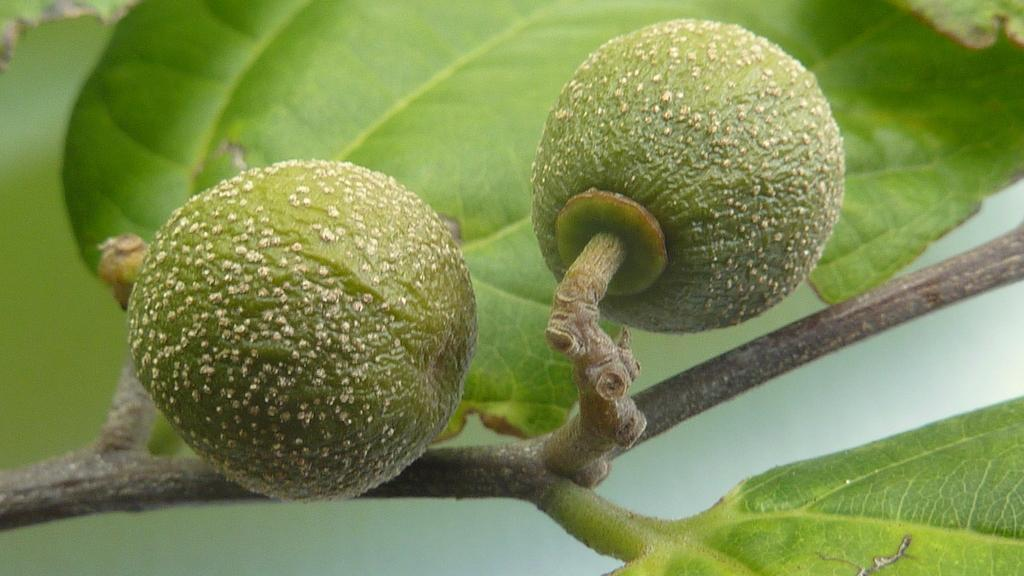What type of plant is visible in the image? The image features a plant with fruits on its stem. Can you describe the fruits on the plant? The fruits are visible on the stem of the plant. What type of skirt is being worn by the instrument in the image? There is no skirt or instrument present in the image; it features a plant with fruits on its stem. 